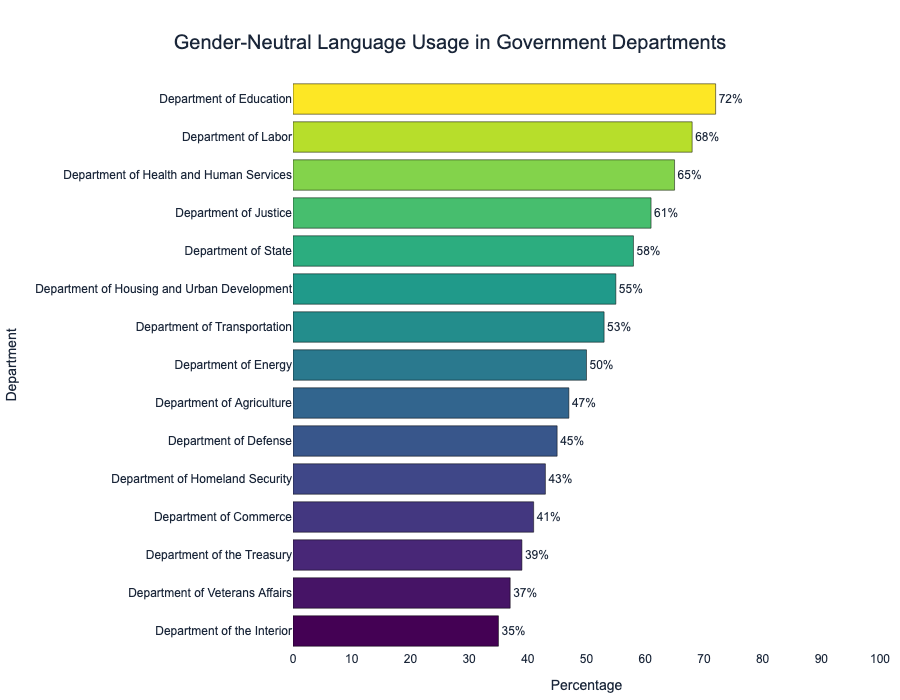What is the department with the highest percentage of gender-neutral language usage? The highest bar on the chart represents the Department of Education with a percentage of 72%, making it the department with the highest usage of gender-neutral language.
Answer: Department of Education Which two departments have the closest percentages of gender-neutral language usage? By visually inspecting the lengths of the bars and their values, the Department of Transportation (53%) and the Department of Energy (50%) have percentages closest to each other, with a difference of 3%.
Answer: Department of Transportation and Department of Energy How much more is the percentage of gender-neutral language usage in the Department of Education compared to the Department of the Interior? The Department of Education has a percentage of 72%, while the Department of the Interior has 35%. Subtracting these values, the difference is 72% - 35% = 37%.
Answer: 37% What is the average percentage of gender-neutral language usage for the top five departments? The percentages for the top five departments are: 72%, 68%, 65%, 61%, and 58%. The sum of these values is 72 + 68 + 65 + 61 + 58 = 324. Dividing by the number of departments, the average is 324 / 5 = 64.8%.
Answer: 64.8% Which department has the lowest percentage of gender-neutral language usage, and what is that percentage? The shortest bar on the chart represents the Department of the Interior with a percentage of 35%, indicating the lowest usage.
Answer: Department of the Interior, 35% Identify any departments with a percentage of gender-neutral language usage below 50%. Departments with percentages below 50% are: Department of Agriculture (47%), Department of Defense (45%), Department of Homeland Security (43%), Department of Commerce (41%), Department of the Treasury (39%), Department of Veterans Affairs (37%), and Department of the Interior (35%).
Answer: Seven departments are below 50% What is the combined percentage of gender-neutral language usage for the Department of Justice and the Department of State? The percentages are: Department of Justice (61%) and Department of State (58%). Adding these values together gives 61% + 58% = 119%.
Answer: 119% Which departments have a usage percentage between 40% and 60%, inclusive? Departments within this range are: Department of Justice (61%), Department of State (58%), Department of Housing and Urban Development (55%), Department of Transportation (53%), Department of Energy (50%), Department of Agriculture (47%), Department of Defense (45%), and Department of Homeland Security (43%).
Answer: Eight departments are between 40% and 60% What is the total range of percentages presented in the chart? The highest percentage is 72% (Department of Education) and the lowest is 35% (Department of the Interior). The range is calculated as 72% - 35% = 37%.
Answer: 37% 